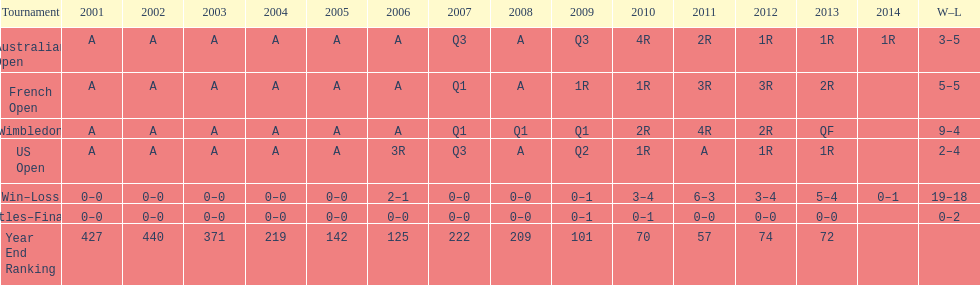In which years was a rank under 200 attained? 2005, 2006, 2009, 2010, 2011, 2012, 2013. 